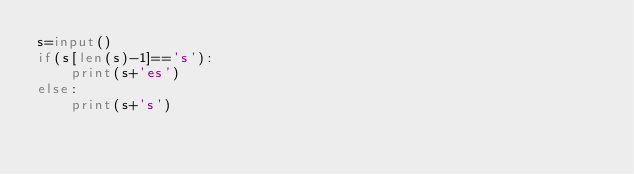<code> <loc_0><loc_0><loc_500><loc_500><_Python_>s=input()
if(s[len(s)-1]=='s'):    
    print(s+'es')
else:
    print(s+'s')</code> 